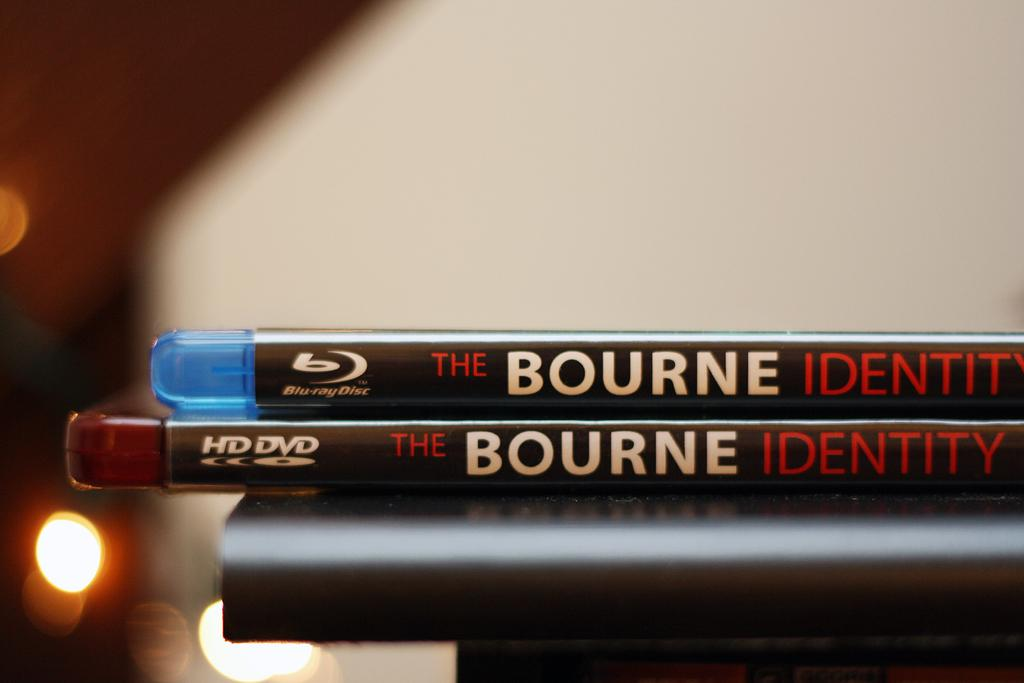Provide a one-sentence caption for the provided image. Two copies of the Bourne Identity are stacked on top of each other. 